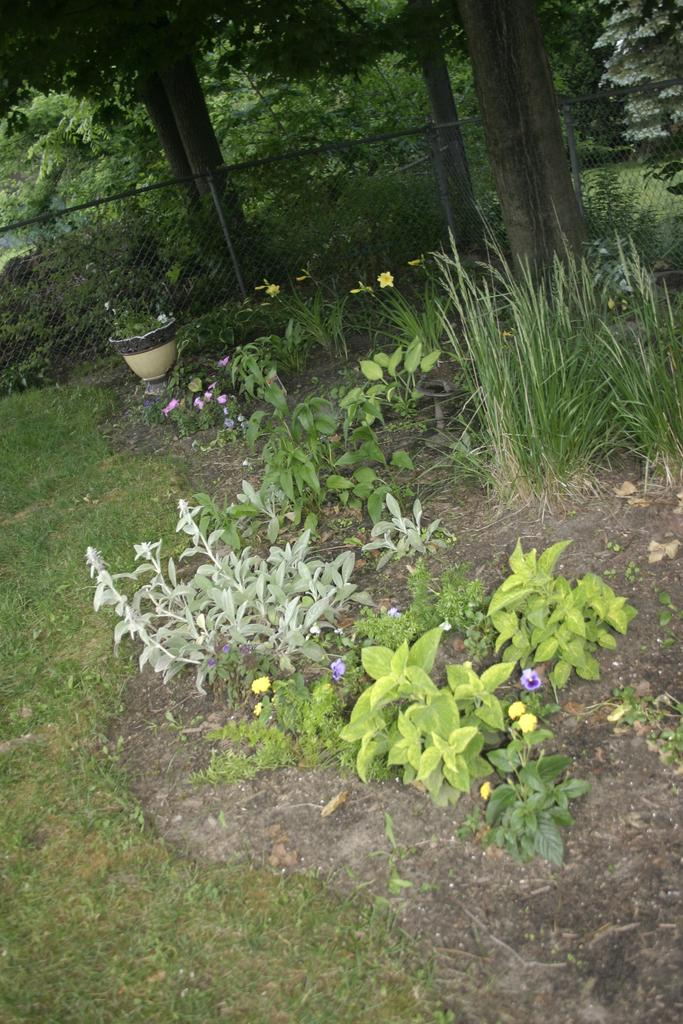What type of vegetation can be seen in the image? There are trees, grass, and plants in the image. Can you describe the natural environment depicted in the image? The image features trees, grass, and plants, which suggests a natural setting. Are there any specific types of plants visible in the image? The facts provided do not specify any particular types of plants, only that there are plants in the image. What kind of trouble can be seen in the image? There is no indication of trouble in the image; it features trees, grass, and plants. Can you tell me the limit of the plants in the image? There is no limit specified for the plants in the image, only that there are plants present. 